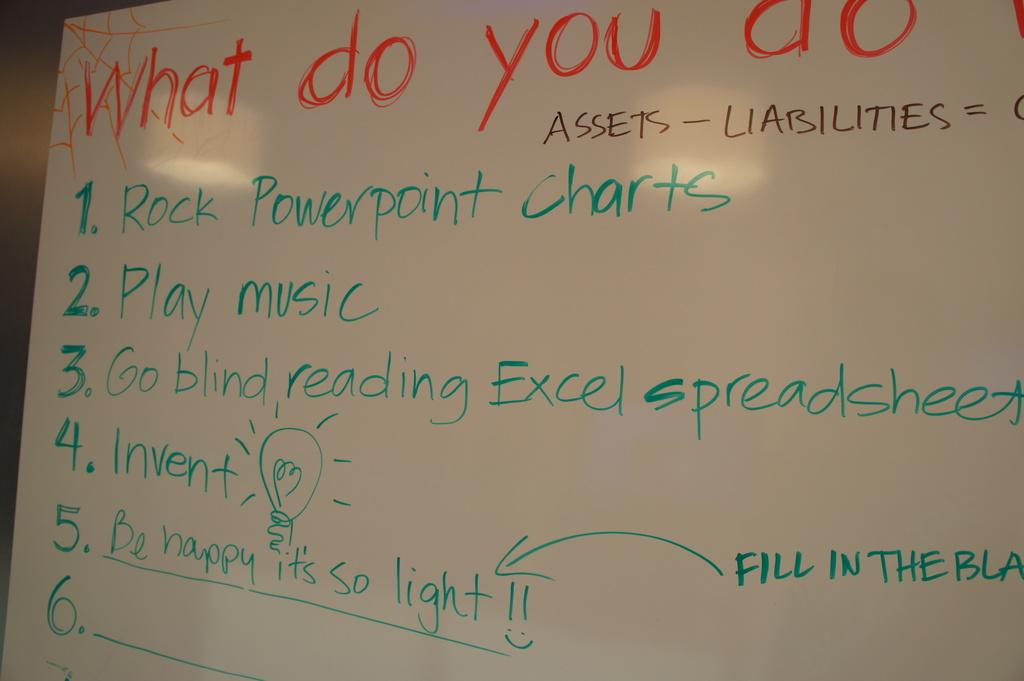<image>
Summarize the visual content of the image. A white board with writing of a list under the heading What do you do with 5 responses. 